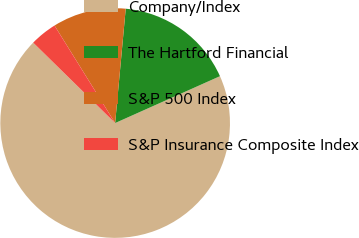<chart> <loc_0><loc_0><loc_500><loc_500><pie_chart><fcel>Company/Index<fcel>The Hartford Financial<fcel>S&P 500 Index<fcel>S&P Insurance Composite Index<nl><fcel>69.04%<fcel>16.84%<fcel>10.32%<fcel>3.8%<nl></chart> 